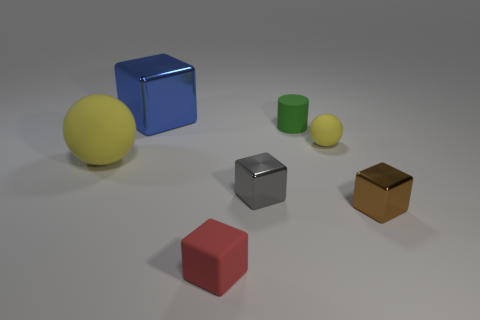There is a sphere that is on the right side of the yellow object on the left side of the tiny red matte object; how many tiny gray objects are behind it?
Give a very brief answer. 0. What number of spheres are either big blue metal objects or tiny red rubber things?
Your answer should be compact. 0. The small rubber thing in front of the yellow sphere behind the matte thing to the left of the small matte block is what color?
Offer a very short reply. Red. How many other things are there of the same size as the blue block?
Make the answer very short. 1. Is there any other thing that has the same shape as the big yellow matte thing?
Make the answer very short. Yes. The matte thing that is the same shape as the big blue shiny object is what color?
Ensure brevity in your answer.  Red. There is a big sphere that is made of the same material as the small yellow thing; what is its color?
Your response must be concise. Yellow. Are there an equal number of large blue metal things on the right side of the red matte object and big cyan objects?
Your answer should be very brief. Yes. There is a yellow ball that is to the right of the blue thing; is it the same size as the tiny red matte object?
Your answer should be very brief. Yes. There is a rubber cylinder that is the same size as the brown metallic block; what color is it?
Provide a succinct answer. Green. 